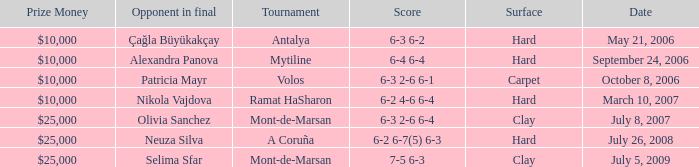What is the score of the hard court Ramat Hasharon tournament? 6-2 4-6 6-4. 